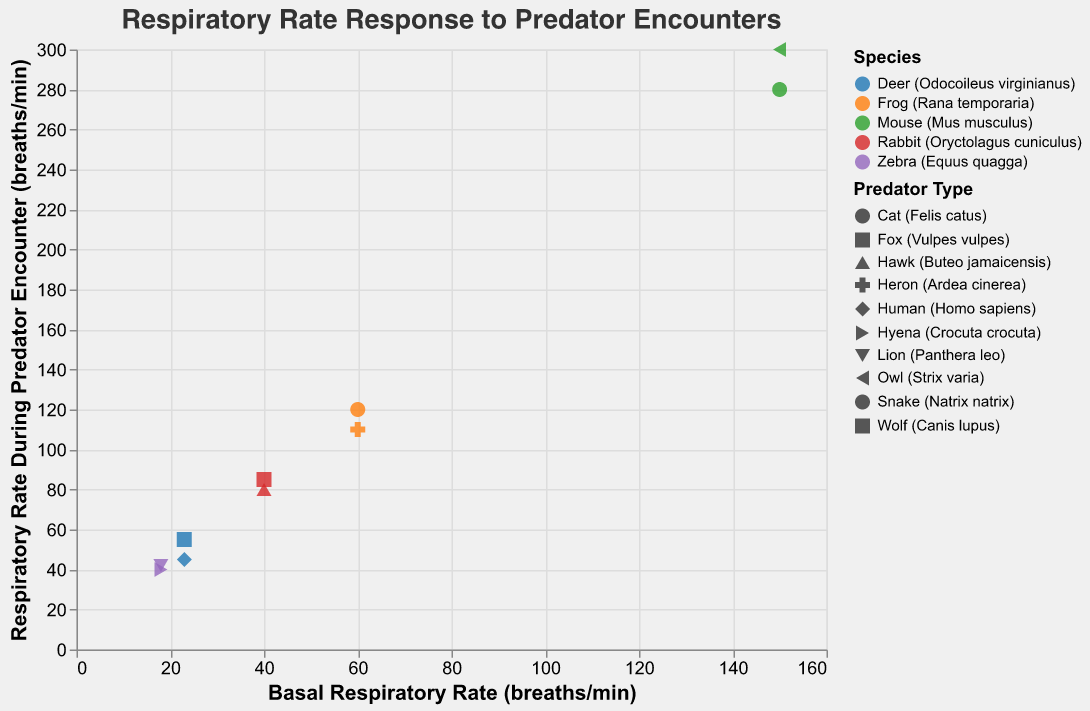What is the overall title of the figure? The overall title of a figure is usually displayed at the top of the chart. In this case, the title is clearly provided at the top in a larger font size.
Answer: Respiratory Rate Response to Predator Encounters What is the range of the x-axis representing the Basal Respiratory Rate? The x-axis range can be determined by looking at the minimum and maximum values in the axis ticks. In this figure, it starts from about 15 and goes up to 160 breaths per minute.
Answer: 15 to 160 breaths/min Which species encounters the predator with the highest increase in respiratory rate? To find this, subtract the Basal Respiratory Rate from the Respiratory Rate During Predator Encounter for each data point, and look for the species with the highest resultant value. The Mouse (Mus musculus) with the Owl (Strix varia) predator shows an increase of 150 breaths per minute (300 - 150).
Answer: Mouse (Mus musculus) How many data points are represented in the scatter plot? Each data point represents a species and its respiratory rate in both basal and predator encounter situations. Counting these, we find the total number of data points.
Answer: 10 What is the shape used to denote encounters with Hyenas (Crocuta crocuta)? Different shapes denote different predator types, which is visible in the legend. By referring to the legend, we find the specific shape for Hyena encounters.
Answer: Specific shape as shown in legend Between the mouse and frog species, which one shows a higher respiratory rate increase when encountering predators? By examining the y-values for the mouse and frog species' predators in comparison to their x-values, we notice that the Mouse (Mus musculus) has a higher increase of 150 breaths per minute compared to the Frog's (60 breaths per minute).
Answer: Mouse (Mus musculus) What is the difference in the respiratory rate increase between a zebra encountering a lion and a zebra encountering a hyena? A Zebra with a Lion predator shows an increase of (42 - 18) = 24 breaths per minute, while with a Hyena, it shows an increase of (40 - 18) = 22 breaths per minute. The difference is 24 - 22 = 2.
Answer: 2 breaths/min Which species has the lowest basal respiratory rate and what is its value? By examining the x-axis, we identify the species with the lowest x-value. The Zebra (Equus quagga) has the lowest basal respiratory rate of 18 breaths per minute.
Answer: Zebra (Equus quagga), 18 breaths/min What is the average respiratory rate during predator encounters for all species? Sum up all the Respiratory Rates During Predator Encounters and divide by the number of data points: (85 + 80 + 55 + 45 + 300 + 280 + 42 + 40 + 120 + 110) / 10 = 1157 / 10 = 115.7.
Answer: 115.7 breaths/min 